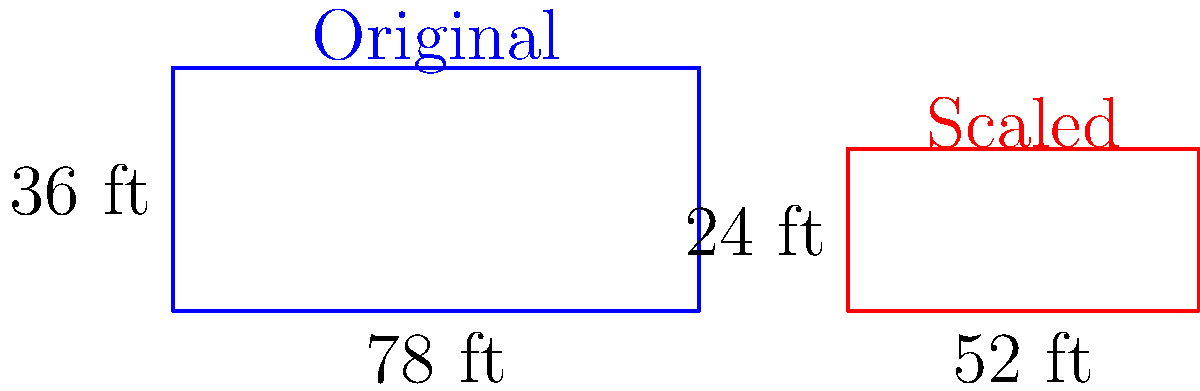As a sports journalist covering local tennis tournaments, you've been asked to report on a new mini-tennis court being built for youth training. The dimensions of a standard tennis court are 78 feet long and 36 feet wide. The new court needs to fit in a space that's only 52 feet long. If the court is scaled proportionally, what will be the width of the new court? To solve this problem, we need to use the concept of scaling in transformational geometry. Here's a step-by-step approach:

1. Identify the scale factor:
   The new length is 52 feet, while the original length is 78 feet.
   Scale factor = New length / Original length = 52 / 78 = 2/3

2. Apply the scale factor to the width:
   Original width = 36 feet
   New width = Original width × Scale factor
   New width = 36 × (2/3)

3. Simplify the calculation:
   New width = (36 × 2) / 3 = 72 / 3 = 24 feet

Therefore, the width of the new scaled-down tennis court will be 24 feet.

This scaling maintains the proportions of the original court, ensuring that the playing experience on the mini-court is similar to that on a full-sized court, which is crucial for youth training and development.
Answer: 24 feet 